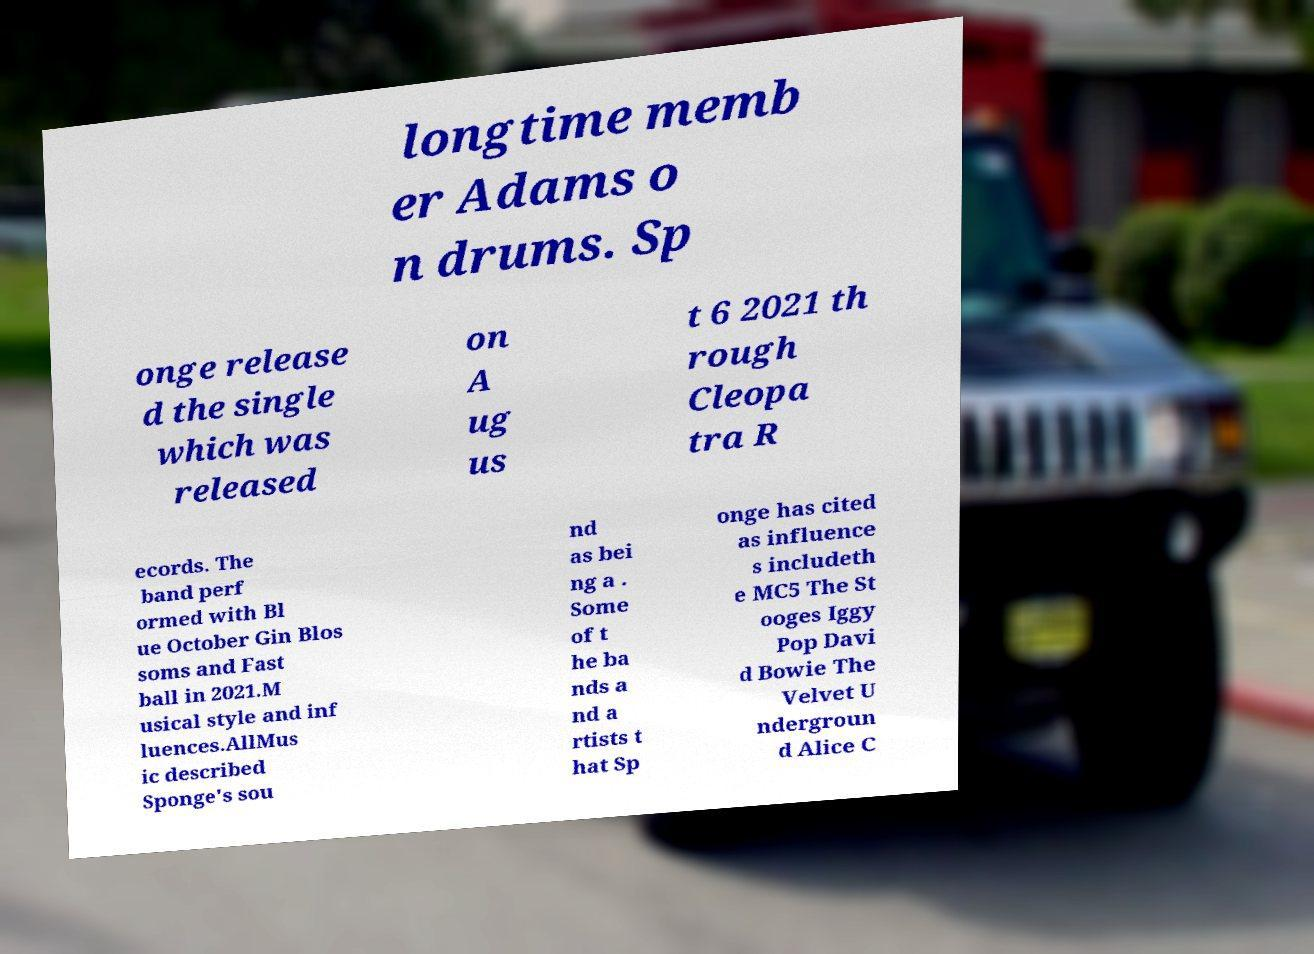What messages or text are displayed in this image? I need them in a readable, typed format. longtime memb er Adams o n drums. Sp onge release d the single which was released on A ug us t 6 2021 th rough Cleopa tra R ecords. The band perf ormed with Bl ue October Gin Blos soms and Fast ball in 2021.M usical style and inf luences.AllMus ic described Sponge's sou nd as bei ng a . Some of t he ba nds a nd a rtists t hat Sp onge has cited as influence s includeth e MC5 The St ooges Iggy Pop Davi d Bowie The Velvet U ndergroun d Alice C 